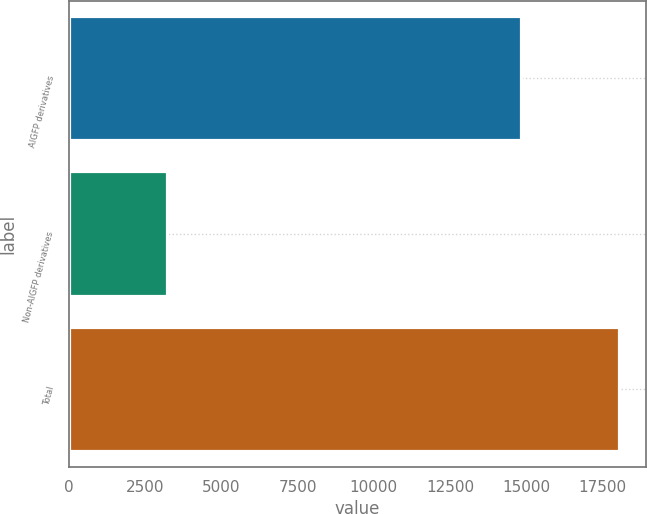Convert chart to OTSL. <chart><loc_0><loc_0><loc_500><loc_500><bar_chart><fcel>AIGFP derivatives<fcel>Non-AIGFP derivatives<fcel>Total<nl><fcel>14817<fcel>3214<fcel>18031<nl></chart> 